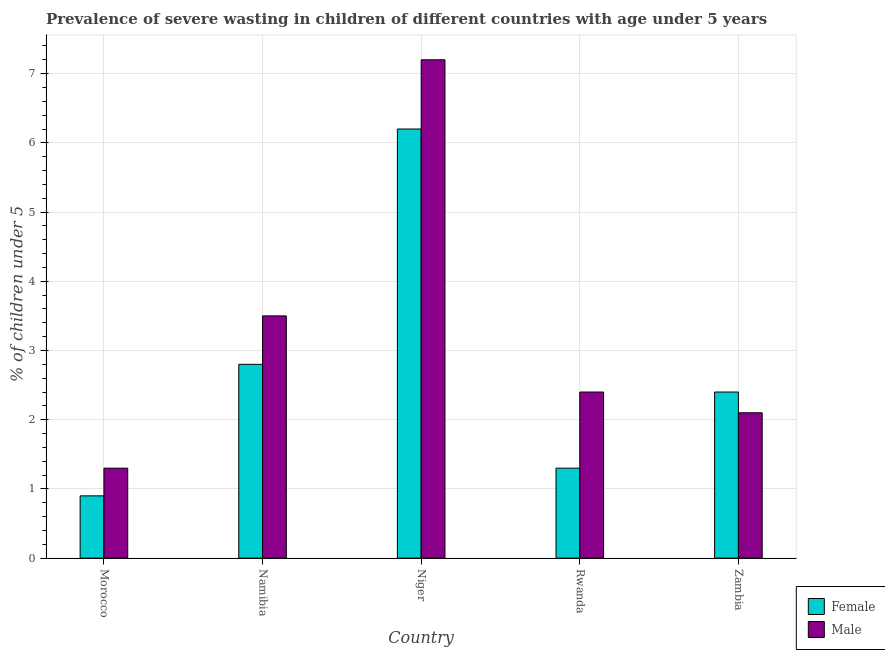How many different coloured bars are there?
Ensure brevity in your answer.  2. How many groups of bars are there?
Your answer should be very brief. 5. How many bars are there on the 5th tick from the left?
Ensure brevity in your answer.  2. What is the label of the 1st group of bars from the left?
Give a very brief answer. Morocco. What is the percentage of undernourished male children in Zambia?
Give a very brief answer. 2.1. Across all countries, what is the maximum percentage of undernourished female children?
Give a very brief answer. 6.2. Across all countries, what is the minimum percentage of undernourished female children?
Give a very brief answer. 0.9. In which country was the percentage of undernourished female children maximum?
Provide a succinct answer. Niger. In which country was the percentage of undernourished female children minimum?
Your answer should be compact. Morocco. What is the total percentage of undernourished female children in the graph?
Provide a succinct answer. 13.6. What is the difference between the percentage of undernourished male children in Morocco and that in Rwanda?
Your response must be concise. -1.1. What is the difference between the percentage of undernourished female children in Niger and the percentage of undernourished male children in Morocco?
Provide a succinct answer. 4.9. What is the average percentage of undernourished male children per country?
Provide a short and direct response. 3.3. What is the difference between the percentage of undernourished female children and percentage of undernourished male children in Morocco?
Your response must be concise. -0.4. In how many countries, is the percentage of undernourished female children greater than 0.4 %?
Keep it short and to the point. 5. What is the ratio of the percentage of undernourished female children in Namibia to that in Niger?
Your answer should be very brief. 0.45. Is the difference between the percentage of undernourished female children in Morocco and Namibia greater than the difference between the percentage of undernourished male children in Morocco and Namibia?
Ensure brevity in your answer.  Yes. What is the difference between the highest and the second highest percentage of undernourished female children?
Give a very brief answer. 3.4. What is the difference between the highest and the lowest percentage of undernourished male children?
Offer a terse response. 5.9. In how many countries, is the percentage of undernourished female children greater than the average percentage of undernourished female children taken over all countries?
Offer a terse response. 2. How many bars are there?
Keep it short and to the point. 10. How many countries are there in the graph?
Provide a succinct answer. 5. Are the values on the major ticks of Y-axis written in scientific E-notation?
Provide a succinct answer. No. Does the graph contain any zero values?
Offer a very short reply. No. Does the graph contain grids?
Your response must be concise. Yes. How many legend labels are there?
Give a very brief answer. 2. What is the title of the graph?
Make the answer very short. Prevalence of severe wasting in children of different countries with age under 5 years. Does "Drinking water services" appear as one of the legend labels in the graph?
Your answer should be compact. No. What is the label or title of the Y-axis?
Make the answer very short.  % of children under 5. What is the  % of children under 5 in Female in Morocco?
Your answer should be very brief. 0.9. What is the  % of children under 5 of Male in Morocco?
Your answer should be compact. 1.3. What is the  % of children under 5 of Female in Namibia?
Keep it short and to the point. 2.8. What is the  % of children under 5 in Female in Niger?
Offer a terse response. 6.2. What is the  % of children under 5 in Male in Niger?
Provide a short and direct response. 7.2. What is the  % of children under 5 of Female in Rwanda?
Your answer should be compact. 1.3. What is the  % of children under 5 in Male in Rwanda?
Make the answer very short. 2.4. What is the  % of children under 5 in Female in Zambia?
Your answer should be compact. 2.4. What is the  % of children under 5 in Male in Zambia?
Offer a terse response. 2.1. Across all countries, what is the maximum  % of children under 5 of Female?
Your response must be concise. 6.2. Across all countries, what is the maximum  % of children under 5 in Male?
Your response must be concise. 7.2. Across all countries, what is the minimum  % of children under 5 of Female?
Offer a terse response. 0.9. Across all countries, what is the minimum  % of children under 5 in Male?
Provide a short and direct response. 1.3. What is the total  % of children under 5 in Female in the graph?
Ensure brevity in your answer.  13.6. What is the total  % of children under 5 of Male in the graph?
Your response must be concise. 16.5. What is the difference between the  % of children under 5 in Male in Morocco and that in Namibia?
Give a very brief answer. -2.2. What is the difference between the  % of children under 5 in Female in Morocco and that in Niger?
Your response must be concise. -5.3. What is the difference between the  % of children under 5 of Male in Morocco and that in Niger?
Keep it short and to the point. -5.9. What is the difference between the  % of children under 5 of Female in Morocco and that in Zambia?
Provide a succinct answer. -1.5. What is the difference between the  % of children under 5 of Male in Morocco and that in Zambia?
Your response must be concise. -0.8. What is the difference between the  % of children under 5 of Male in Namibia and that in Rwanda?
Keep it short and to the point. 1.1. What is the difference between the  % of children under 5 of Male in Namibia and that in Zambia?
Your response must be concise. 1.4. What is the difference between the  % of children under 5 of Male in Niger and that in Rwanda?
Offer a very short reply. 4.8. What is the difference between the  % of children under 5 of Female in Niger and that in Zambia?
Your answer should be very brief. 3.8. What is the difference between the  % of children under 5 in Male in Niger and that in Zambia?
Offer a terse response. 5.1. What is the difference between the  % of children under 5 of Female in Rwanda and that in Zambia?
Offer a terse response. -1.1. What is the difference between the  % of children under 5 of Male in Rwanda and that in Zambia?
Your answer should be compact. 0.3. What is the difference between the  % of children under 5 in Female in Morocco and the  % of children under 5 in Male in Namibia?
Ensure brevity in your answer.  -2.6. What is the difference between the  % of children under 5 in Female in Morocco and the  % of children under 5 in Male in Niger?
Ensure brevity in your answer.  -6.3. What is the difference between the  % of children under 5 in Female in Namibia and the  % of children under 5 in Male in Niger?
Provide a succinct answer. -4.4. What is the difference between the  % of children under 5 of Female in Namibia and the  % of children under 5 of Male in Rwanda?
Keep it short and to the point. 0.4. What is the difference between the  % of children under 5 in Female in Niger and the  % of children under 5 in Male in Zambia?
Provide a short and direct response. 4.1. What is the difference between the  % of children under 5 in Female in Rwanda and the  % of children under 5 in Male in Zambia?
Your response must be concise. -0.8. What is the average  % of children under 5 in Female per country?
Your answer should be compact. 2.72. What is the average  % of children under 5 of Male per country?
Make the answer very short. 3.3. What is the difference between the  % of children under 5 of Female and  % of children under 5 of Male in Namibia?
Offer a very short reply. -0.7. What is the difference between the  % of children under 5 in Female and  % of children under 5 in Male in Niger?
Your answer should be very brief. -1. What is the difference between the  % of children under 5 in Female and  % of children under 5 in Male in Rwanda?
Offer a terse response. -1.1. What is the ratio of the  % of children under 5 of Female in Morocco to that in Namibia?
Give a very brief answer. 0.32. What is the ratio of the  % of children under 5 in Male in Morocco to that in Namibia?
Make the answer very short. 0.37. What is the ratio of the  % of children under 5 in Female in Morocco to that in Niger?
Offer a terse response. 0.15. What is the ratio of the  % of children under 5 of Male in Morocco to that in Niger?
Offer a terse response. 0.18. What is the ratio of the  % of children under 5 in Female in Morocco to that in Rwanda?
Provide a short and direct response. 0.69. What is the ratio of the  % of children under 5 in Male in Morocco to that in Rwanda?
Provide a succinct answer. 0.54. What is the ratio of the  % of children under 5 of Female in Morocco to that in Zambia?
Ensure brevity in your answer.  0.38. What is the ratio of the  % of children under 5 of Male in Morocco to that in Zambia?
Offer a very short reply. 0.62. What is the ratio of the  % of children under 5 of Female in Namibia to that in Niger?
Offer a terse response. 0.45. What is the ratio of the  % of children under 5 of Male in Namibia to that in Niger?
Your answer should be very brief. 0.49. What is the ratio of the  % of children under 5 of Female in Namibia to that in Rwanda?
Provide a short and direct response. 2.15. What is the ratio of the  % of children under 5 of Male in Namibia to that in Rwanda?
Provide a succinct answer. 1.46. What is the ratio of the  % of children under 5 of Female in Niger to that in Rwanda?
Your response must be concise. 4.77. What is the ratio of the  % of children under 5 in Male in Niger to that in Rwanda?
Provide a succinct answer. 3. What is the ratio of the  % of children under 5 in Female in Niger to that in Zambia?
Ensure brevity in your answer.  2.58. What is the ratio of the  % of children under 5 in Male in Niger to that in Zambia?
Provide a short and direct response. 3.43. What is the ratio of the  % of children under 5 of Female in Rwanda to that in Zambia?
Provide a short and direct response. 0.54. What is the ratio of the  % of children under 5 in Male in Rwanda to that in Zambia?
Give a very brief answer. 1.14. What is the difference between the highest and the second highest  % of children under 5 in Female?
Make the answer very short. 3.4. What is the difference between the highest and the second highest  % of children under 5 of Male?
Your answer should be very brief. 3.7. 